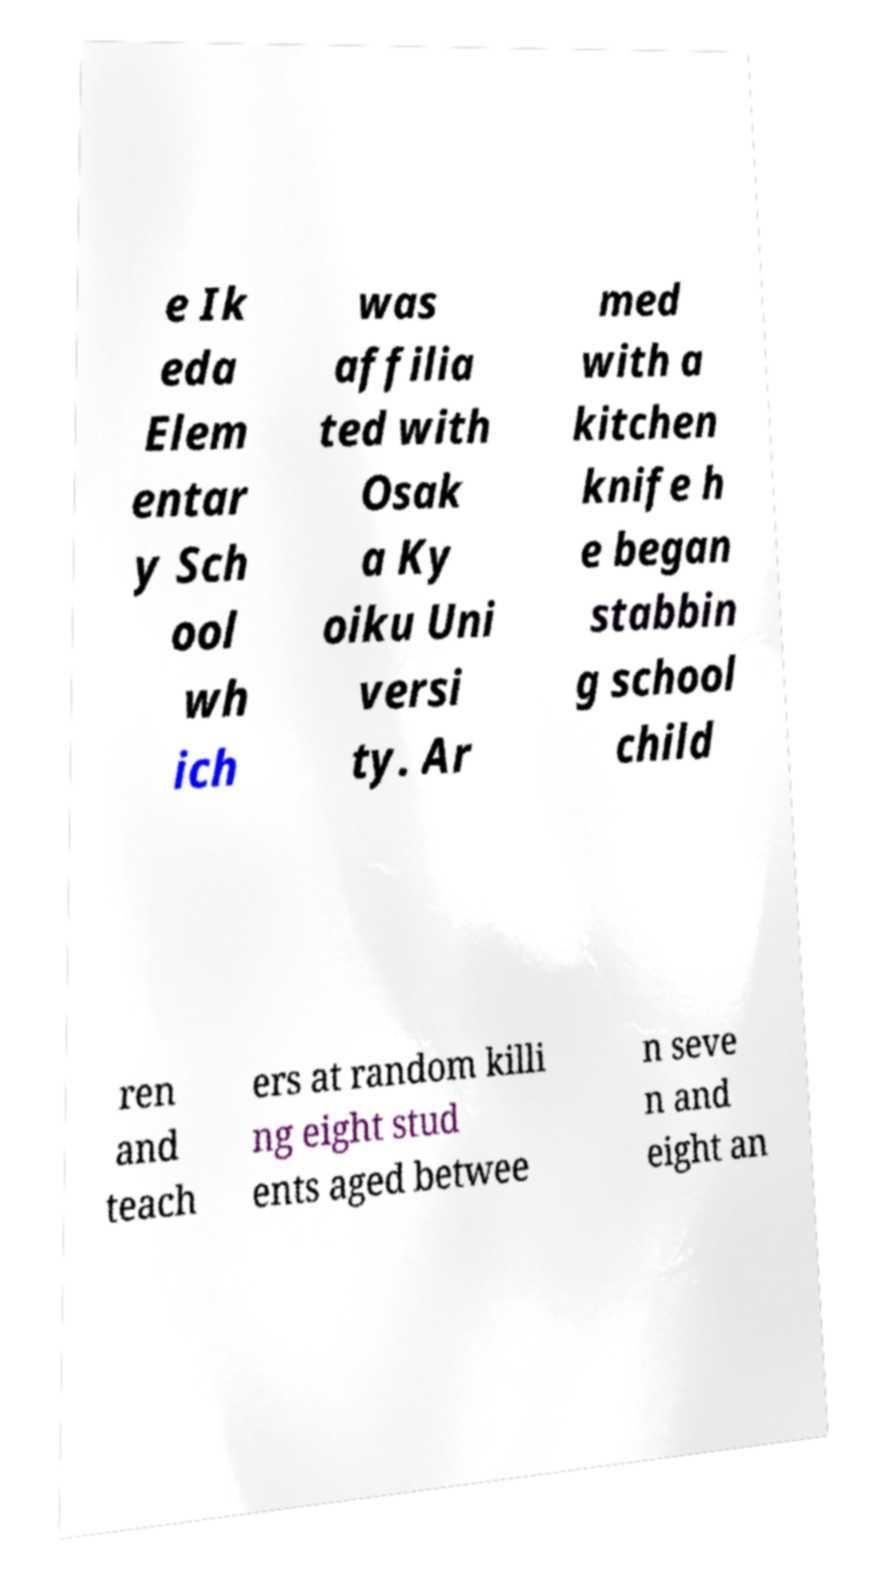Please read and relay the text visible in this image. What does it say? e Ik eda Elem entar y Sch ool wh ich was affilia ted with Osak a Ky oiku Uni versi ty. Ar med with a kitchen knife h e began stabbin g school child ren and teach ers at random killi ng eight stud ents aged betwee n seve n and eight an 